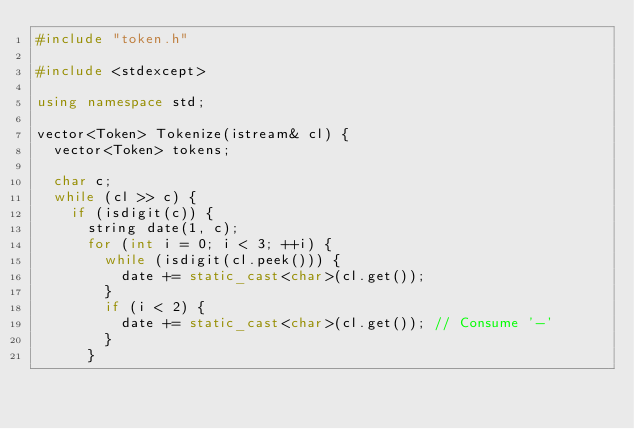<code> <loc_0><loc_0><loc_500><loc_500><_C++_>#include "token.h"

#include <stdexcept>

using namespace std;

vector<Token> Tokenize(istream& cl) {
  vector<Token> tokens;

  char c;
  while (cl >> c) {
    if (isdigit(c)) {
      string date(1, c);
      for (int i = 0; i < 3; ++i) {
        while (isdigit(cl.peek())) {
          date += static_cast<char>(cl.get());
        }
        if (i < 2) {
          date += static_cast<char>(cl.get()); // Consume '-'
        }
      }</code> 